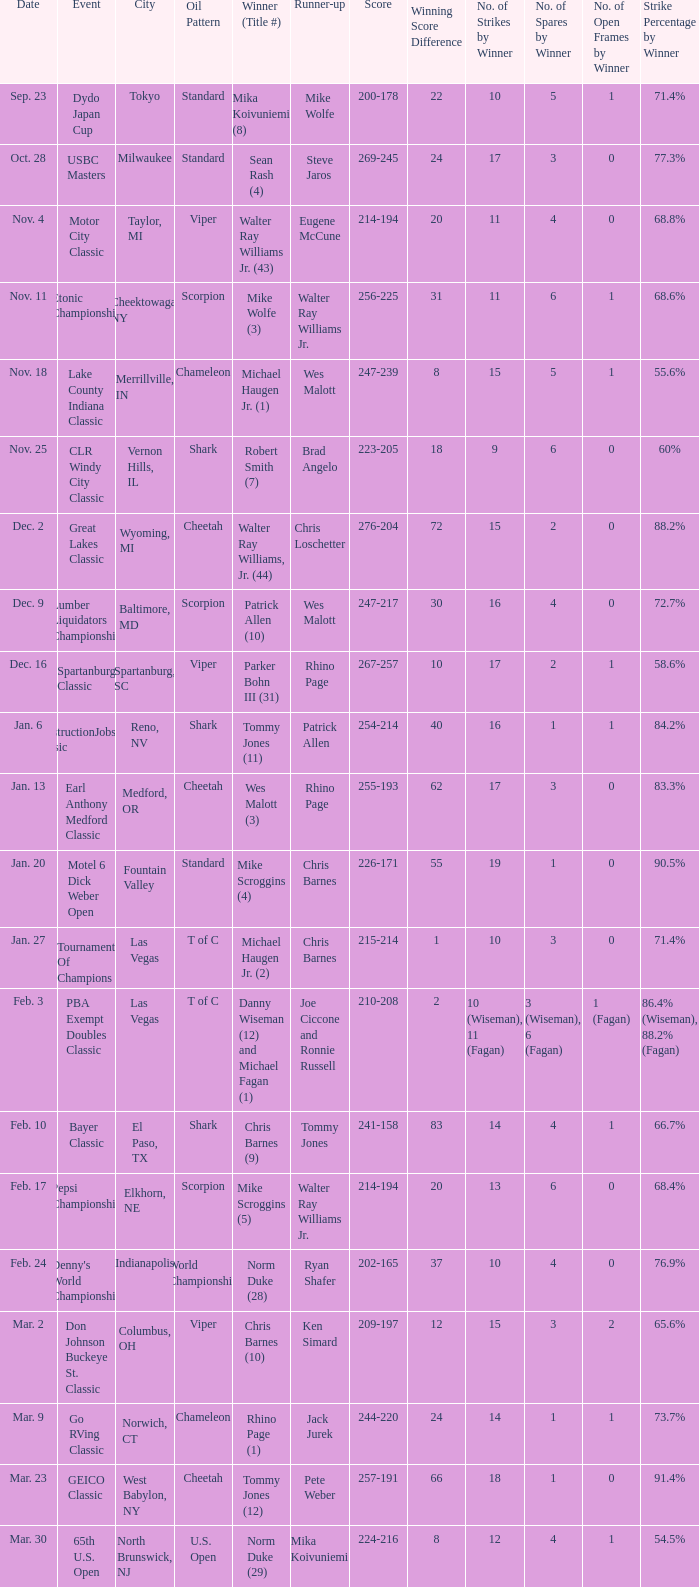Which Oil Pattern has a Winner (Title #) of mike wolfe (3)? Scorpion. Could you help me parse every detail presented in this table? {'header': ['Date', 'Event', 'City', 'Oil Pattern', 'Winner (Title #)', 'Runner-up', 'Score', 'Winning Score Difference', 'No. of Strikes by Winner', 'No. of Spares by Winner', 'No. of Open Frames by Winner', 'Strike Percentage by Winner'], 'rows': [['Sep. 23', 'Dydo Japan Cup', 'Tokyo', 'Standard', 'Mika Koivuniemi (8)', 'Mike Wolfe', '200-178', '22', '10', '5', '1', '71.4%'], ['Oct. 28', 'USBC Masters', 'Milwaukee', 'Standard', 'Sean Rash (4)', 'Steve Jaros', '269-245', '24', '17', '3', '0', '77.3%'], ['Nov. 4', 'Motor City Classic', 'Taylor, MI', 'Viper', 'Walter Ray Williams Jr. (43)', 'Eugene McCune', '214-194', '20', '11', '4', '0', '68.8%'], ['Nov. 11', 'Etonic Championship', 'Cheektowaga, NY', 'Scorpion', 'Mike Wolfe (3)', 'Walter Ray Williams Jr.', '256-225', '31', '11', '6', '1', '68.6%'], ['Nov. 18', 'Lake County Indiana Classic', 'Merrillville, IN', 'Chameleon', 'Michael Haugen Jr. (1)', 'Wes Malott', '247-239', '8', '15', '5', '1', '55.6%'], ['Nov. 25', 'CLR Windy City Classic', 'Vernon Hills, IL', 'Shark', 'Robert Smith (7)', 'Brad Angelo', '223-205', '18', '9', '6', '0', '60%'], ['Dec. 2', 'Great Lakes Classic', 'Wyoming, MI', 'Cheetah', 'Walter Ray Williams, Jr. (44)', 'Chris Loschetter', '276-204', '72', '15', '2', '0', '88.2%'], ['Dec. 9', 'Lumber Liquidators Championship', 'Baltimore, MD', 'Scorpion', 'Patrick Allen (10)', 'Wes Malott', '247-217', '30', '16', '4', '0', '72.7%'], ['Dec. 16', 'Spartanburg Classic', 'Spartanburg, SC', 'Viper', 'Parker Bohn III (31)', 'Rhino Page', '267-257', '10', '17', '2', '1', '58.6%'], ['Jan. 6', 'ConstructionJobs.com Classic', 'Reno, NV', 'Shark', 'Tommy Jones (11)', 'Patrick Allen', '254-214', '40', '16', '1', '1', '84.2%'], ['Jan. 13', 'Earl Anthony Medford Classic', 'Medford, OR', 'Cheetah', 'Wes Malott (3)', 'Rhino Page', '255-193', '62', '17', '3', '0', '83.3%'], ['Jan. 20', 'Motel 6 Dick Weber Open', 'Fountain Valley', 'Standard', 'Mike Scroggins (4)', 'Chris Barnes', '226-171', '55', '19', '1', '0', '90.5%'], ['Jan. 27', 'Tournament Of Champions', 'Las Vegas', 'T of C', 'Michael Haugen Jr. (2)', 'Chris Barnes', '215-214', '1', '10', '3', '0', '71.4%'], ['Feb. 3', 'PBA Exempt Doubles Classic', 'Las Vegas', 'T of C', 'Danny Wiseman (12) and Michael Fagan (1)', 'Joe Ciccone and Ronnie Russell', '210-208', '2', '10 (Wiseman), 11 (Fagan)', '3 (Wiseman), 6 (Fagan)', '1 (Fagan)', '86.4% (Wiseman), 88.2% (Fagan)'], ['Feb. 10', 'Bayer Classic', 'El Paso, TX', 'Shark', 'Chris Barnes (9)', 'Tommy Jones', '241-158', '83', '14', '4', '1', '66.7%'], ['Feb. 17', 'Pepsi Championship', 'Elkhorn, NE', 'Scorpion', 'Mike Scroggins (5)', 'Walter Ray Williams Jr.', '214-194', '20', '13', '6', '0', '68.4%'], ['Feb. 24', "Denny's World Championship", 'Indianapolis', 'World Championship', 'Norm Duke (28)', 'Ryan Shafer', '202-165', '37', '10', '4', '0', '76.9%'], ['Mar. 2', 'Don Johnson Buckeye St. Classic', 'Columbus, OH', 'Viper', 'Chris Barnes (10)', 'Ken Simard', '209-197', '12', '15', '3', '2', '65.6%'], ['Mar. 9', 'Go RVing Classic', 'Norwich, CT', 'Chameleon', 'Rhino Page (1)', 'Jack Jurek', '244-220', '24', '14', '1', '1', '73.7%'], ['Mar. 23', 'GEICO Classic', 'West Babylon, NY', 'Cheetah', 'Tommy Jones (12)', 'Pete Weber', '257-191', '66', '18', '1', '0', '91.4%'], ['Mar. 30', '65th U.S. Open', 'North Brunswick, NJ', 'U.S. Open', 'Norm Duke (29)', 'Mika Koivuniemi', '224-216', '8', '12', '4', '1', '54.5%']]} 